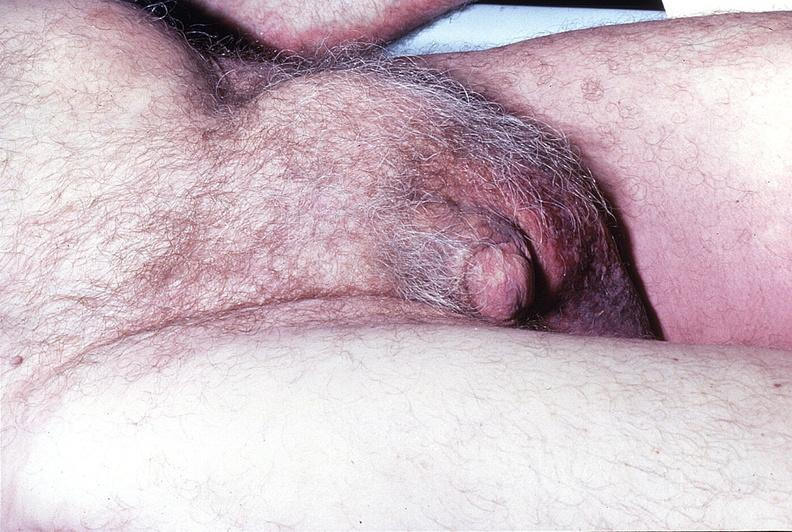does this image show inguinal hernia?
Answer the question using a single word or phrase. Yes 